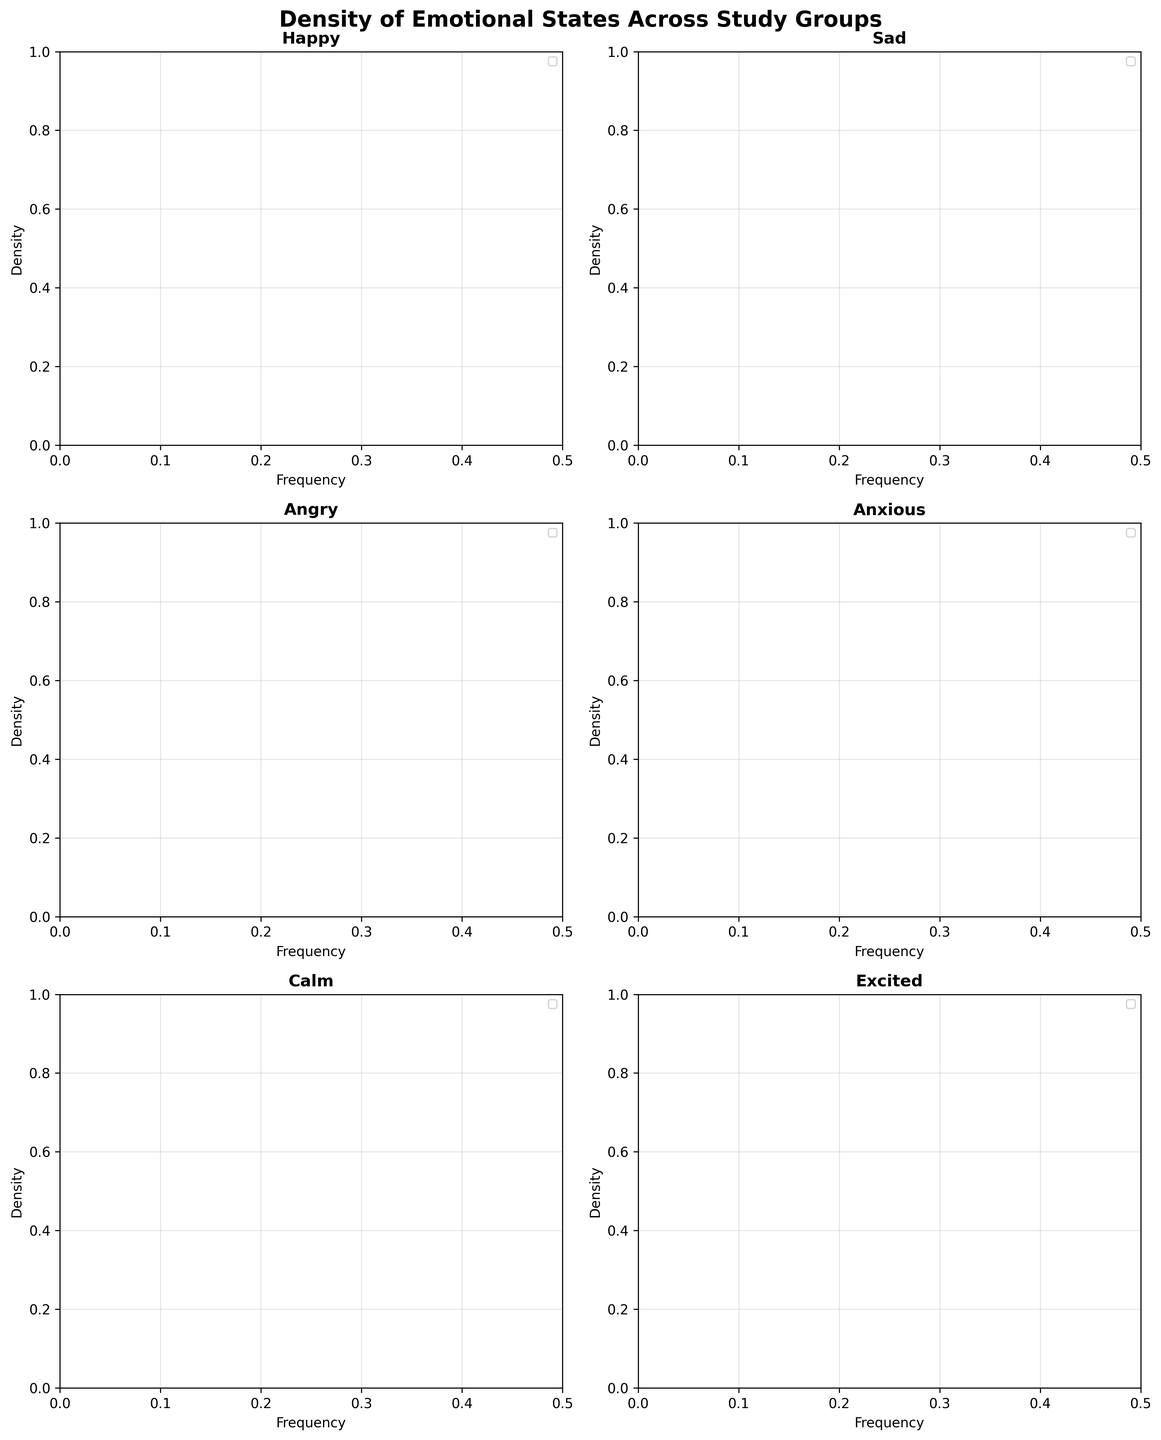What is the title of the figure? The title of the figure is located at the top center and is usually the largest text.
Answer: Density of Emotional States Across Study Groups Which emotion shows the highest frequency in the Control group? By examining the density plots for each emotion, the 'Happy' plot for the Control group has the highest peak frequency, around 0.32.
Answer: Happy Which study group has the lowest frequency of feeling 'Calm'? We need to look at the 'Calm' subplot and find the study group with the lowest peak frequency. The 'Anxiety' group shows the lowest peak, around 0.08.
Answer: Anxiety For the emotion 'Sad', which study group has the highest density peak? By analyzing the 'Sad' subplot, the 'Depression' group exhibits the highest density peak, around 0.35.
Answer: Depression What is the range of frequencies for the 'Angry' emotion across all study groups? The 'Angry' subplot shows that the frequencies range from approximately 0.10 to 0.22 across all study groups.
Answer: 0.10 to 0.22 Between the 'Happy' and 'Anxious' emotions, which shows greater variance in frequency among the study groups? Comparison of the range in the 'Happy' subplot (0.28 to 0.35) with the range in the 'Anxious' subplot (0.12 to 0.38) indicates that 'Anxious' has greater variance.
Answer: Anxious Which study group has a similar pattern in the density plots for 'Happy' and 'Excited'? By comparing the 'Happy' and 'Excited' subplots, the 'Control' group has similar density distributions in both, with peaks at 0.32 for 'Happy' and 0.18 for 'Excited'.
Answer: Control What overall trend can be observed in the 'Excited' emotion across all study groups? Analyzing the 'Excited' subplot shows that the frequency of feeling 'Excited' is noticeably lower in Depression, Anxiety, and PTSD groups compared to the Control group, indicating a downward trend.
Answer: Downward trend In the 'Calm' subplot, which study group shows the most significant difference from the Control group? The 'Calm' subplot indicates that the 'Depression' group differs the most, showing a peak at 0.10 compared to 0.25 in the Control group.
Answer: Depression 